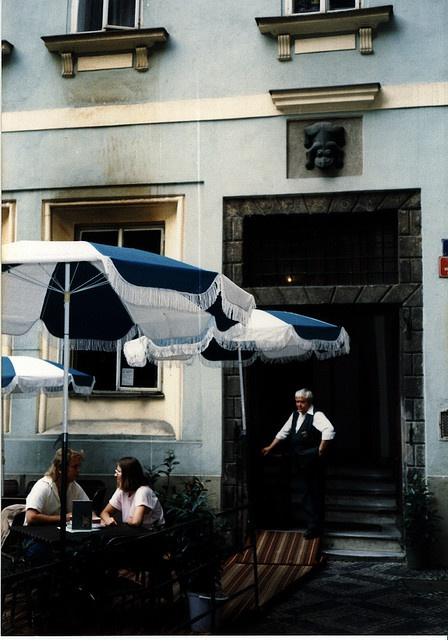Describe the objects in this image and their specific colors. I can see umbrella in lavender, darkgray, black, white, and teal tones, umbrella in lavender, black, lightgray, darkgray, and gray tones, people in lavender, black, lightgray, darkgray, and gray tones, umbrella in lavender, white, darkgray, black, and gray tones, and people in lavender, black, darkgray, lightgray, and tan tones in this image. 